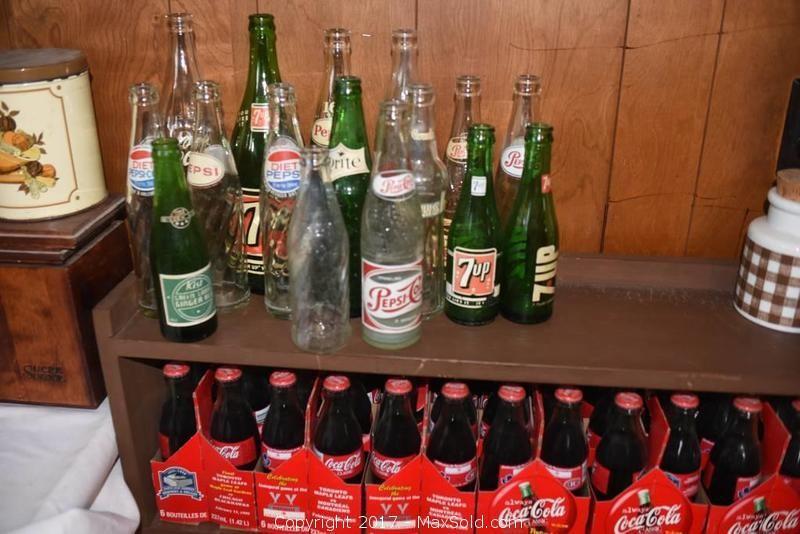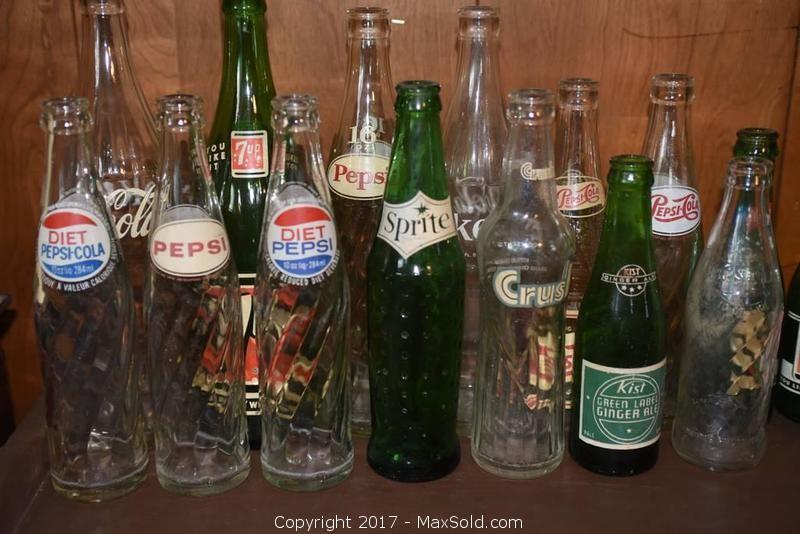The first image is the image on the left, the second image is the image on the right. Assess this claim about the two images: "All the bottles in these images are unopened and full of a beverage.". Correct or not? Answer yes or no. No. The first image is the image on the left, the second image is the image on the right. Considering the images on both sides, is "There are empty bottles sitting on a shelf." valid? Answer yes or no. Yes. 